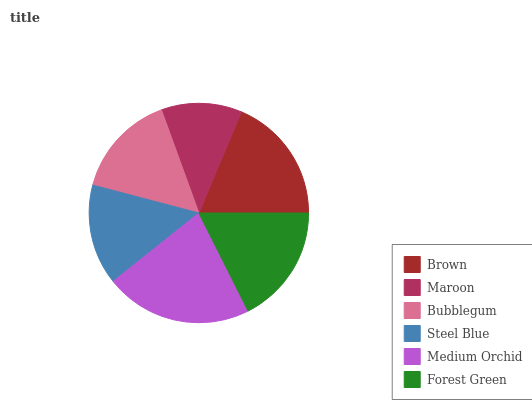Is Maroon the minimum?
Answer yes or no. Yes. Is Medium Orchid the maximum?
Answer yes or no. Yes. Is Bubblegum the minimum?
Answer yes or no. No. Is Bubblegum the maximum?
Answer yes or no. No. Is Bubblegum greater than Maroon?
Answer yes or no. Yes. Is Maroon less than Bubblegum?
Answer yes or no. Yes. Is Maroon greater than Bubblegum?
Answer yes or no. No. Is Bubblegum less than Maroon?
Answer yes or no. No. Is Forest Green the high median?
Answer yes or no. Yes. Is Bubblegum the low median?
Answer yes or no. Yes. Is Steel Blue the high median?
Answer yes or no. No. Is Maroon the low median?
Answer yes or no. No. 